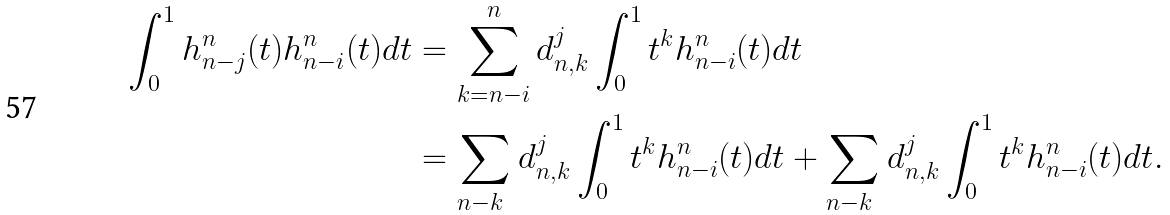<formula> <loc_0><loc_0><loc_500><loc_500>\int _ { 0 } ^ { 1 } h ^ { n } _ { n - j } ( t ) h ^ { n } _ { n - i } ( t ) d t & = \sum _ { k = n - i } ^ { n } d _ { n , k } ^ { j } \int _ { 0 } ^ { 1 } t ^ { k } h ^ { n } _ { n - i } ( t ) d t \\ & = \sum _ { n - k \ } d _ { n , k } ^ { j } \int _ { 0 } ^ { 1 } t ^ { k } h ^ { n } _ { n - i } ( t ) d t + \sum _ { n - k \ } d _ { n , k } ^ { j } \int _ { 0 } ^ { 1 } t ^ { k } h ^ { n } _ { n - i } ( t ) d t .</formula> 